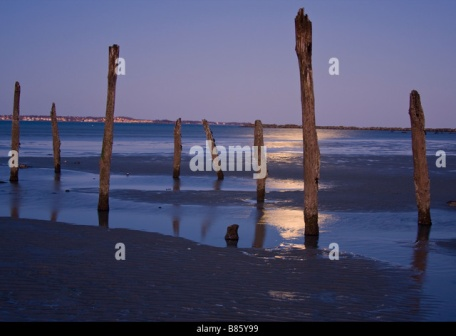Imagine this location decades into the future. What changes do you foresee? Decades into the future, the beach could undergo numerous changes due to natural and human influences. The wooden poles, continually exposed to the elements, might become more weathered, some perhaps even succumbing to the ceaseless wear of wind and tide, or being replaced by new markers. The coastline might shift, with sand and water levels altering due to erosion or rising sea levels. Human activity, if it increases, might lead to the development of structures or amenities, potentially changing the secluded, untouched feel of the location. Alternatively, conservation efforts could preserve its natural beauty, ensuring it remains a serene escape from the hustle and bustle of modern life. 